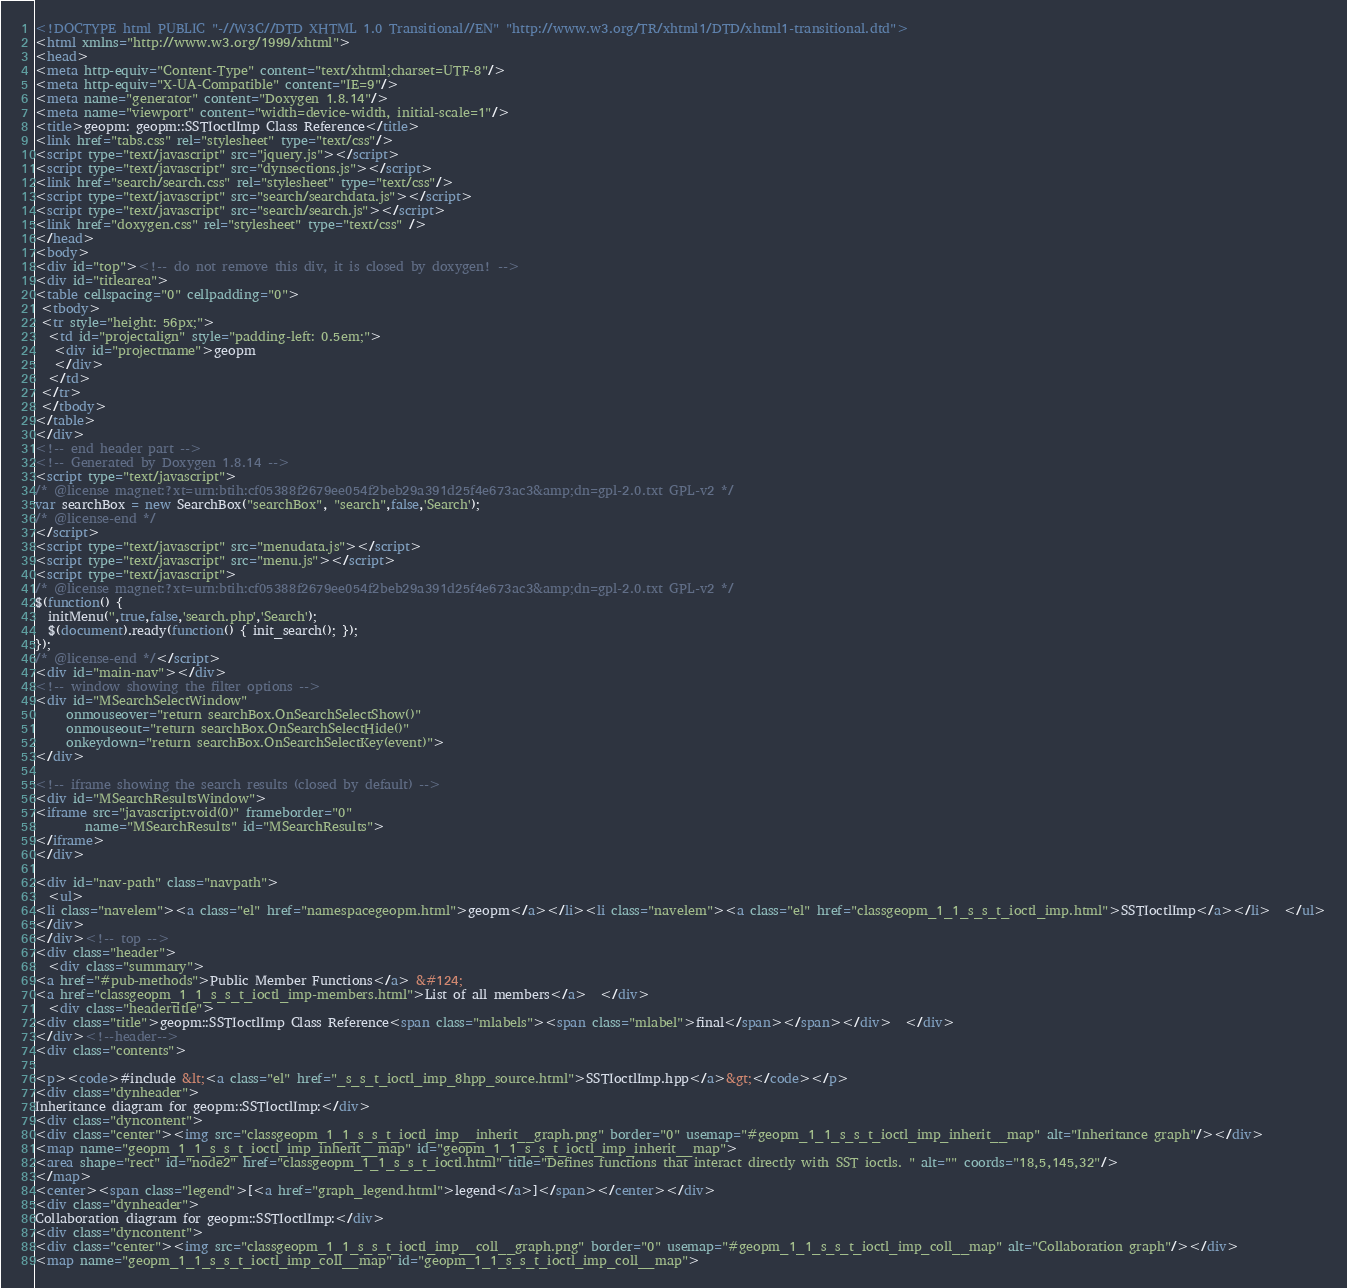<code> <loc_0><loc_0><loc_500><loc_500><_HTML_><!DOCTYPE html PUBLIC "-//W3C//DTD XHTML 1.0 Transitional//EN" "http://www.w3.org/TR/xhtml1/DTD/xhtml1-transitional.dtd">
<html xmlns="http://www.w3.org/1999/xhtml">
<head>
<meta http-equiv="Content-Type" content="text/xhtml;charset=UTF-8"/>
<meta http-equiv="X-UA-Compatible" content="IE=9"/>
<meta name="generator" content="Doxygen 1.8.14"/>
<meta name="viewport" content="width=device-width, initial-scale=1"/>
<title>geopm: geopm::SSTIoctlImp Class Reference</title>
<link href="tabs.css" rel="stylesheet" type="text/css"/>
<script type="text/javascript" src="jquery.js"></script>
<script type="text/javascript" src="dynsections.js"></script>
<link href="search/search.css" rel="stylesheet" type="text/css"/>
<script type="text/javascript" src="search/searchdata.js"></script>
<script type="text/javascript" src="search/search.js"></script>
<link href="doxygen.css" rel="stylesheet" type="text/css" />
</head>
<body>
<div id="top"><!-- do not remove this div, it is closed by doxygen! -->
<div id="titlearea">
<table cellspacing="0" cellpadding="0">
 <tbody>
 <tr style="height: 56px;">
  <td id="projectalign" style="padding-left: 0.5em;">
   <div id="projectname">geopm
   </div>
  </td>
 </tr>
 </tbody>
</table>
</div>
<!-- end header part -->
<!-- Generated by Doxygen 1.8.14 -->
<script type="text/javascript">
/* @license magnet:?xt=urn:btih:cf05388f2679ee054f2beb29a391d25f4e673ac3&amp;dn=gpl-2.0.txt GPL-v2 */
var searchBox = new SearchBox("searchBox", "search",false,'Search');
/* @license-end */
</script>
<script type="text/javascript" src="menudata.js"></script>
<script type="text/javascript" src="menu.js"></script>
<script type="text/javascript">
/* @license magnet:?xt=urn:btih:cf05388f2679ee054f2beb29a391d25f4e673ac3&amp;dn=gpl-2.0.txt GPL-v2 */
$(function() {
  initMenu('',true,false,'search.php','Search');
  $(document).ready(function() { init_search(); });
});
/* @license-end */</script>
<div id="main-nav"></div>
<!-- window showing the filter options -->
<div id="MSearchSelectWindow"
     onmouseover="return searchBox.OnSearchSelectShow()"
     onmouseout="return searchBox.OnSearchSelectHide()"
     onkeydown="return searchBox.OnSearchSelectKey(event)">
</div>

<!-- iframe showing the search results (closed by default) -->
<div id="MSearchResultsWindow">
<iframe src="javascript:void(0)" frameborder="0" 
        name="MSearchResults" id="MSearchResults">
</iframe>
</div>

<div id="nav-path" class="navpath">
  <ul>
<li class="navelem"><a class="el" href="namespacegeopm.html">geopm</a></li><li class="navelem"><a class="el" href="classgeopm_1_1_s_s_t_ioctl_imp.html">SSTIoctlImp</a></li>  </ul>
</div>
</div><!-- top -->
<div class="header">
  <div class="summary">
<a href="#pub-methods">Public Member Functions</a> &#124;
<a href="classgeopm_1_1_s_s_t_ioctl_imp-members.html">List of all members</a>  </div>
  <div class="headertitle">
<div class="title">geopm::SSTIoctlImp Class Reference<span class="mlabels"><span class="mlabel">final</span></span></div>  </div>
</div><!--header-->
<div class="contents">

<p><code>#include &lt;<a class="el" href="_s_s_t_ioctl_imp_8hpp_source.html">SSTIoctlImp.hpp</a>&gt;</code></p>
<div class="dynheader">
Inheritance diagram for geopm::SSTIoctlImp:</div>
<div class="dyncontent">
<div class="center"><img src="classgeopm_1_1_s_s_t_ioctl_imp__inherit__graph.png" border="0" usemap="#geopm_1_1_s_s_t_ioctl_imp_inherit__map" alt="Inheritance graph"/></div>
<map name="geopm_1_1_s_s_t_ioctl_imp_inherit__map" id="geopm_1_1_s_s_t_ioctl_imp_inherit__map">
<area shape="rect" id="node2" href="classgeopm_1_1_s_s_t_ioctl.html" title="Defines functions that interact directly with SST ioctls. " alt="" coords="18,5,145,32"/>
</map>
<center><span class="legend">[<a href="graph_legend.html">legend</a>]</span></center></div>
<div class="dynheader">
Collaboration diagram for geopm::SSTIoctlImp:</div>
<div class="dyncontent">
<div class="center"><img src="classgeopm_1_1_s_s_t_ioctl_imp__coll__graph.png" border="0" usemap="#geopm_1_1_s_s_t_ioctl_imp_coll__map" alt="Collaboration graph"/></div>
<map name="geopm_1_1_s_s_t_ioctl_imp_coll__map" id="geopm_1_1_s_s_t_ioctl_imp_coll__map"></code> 